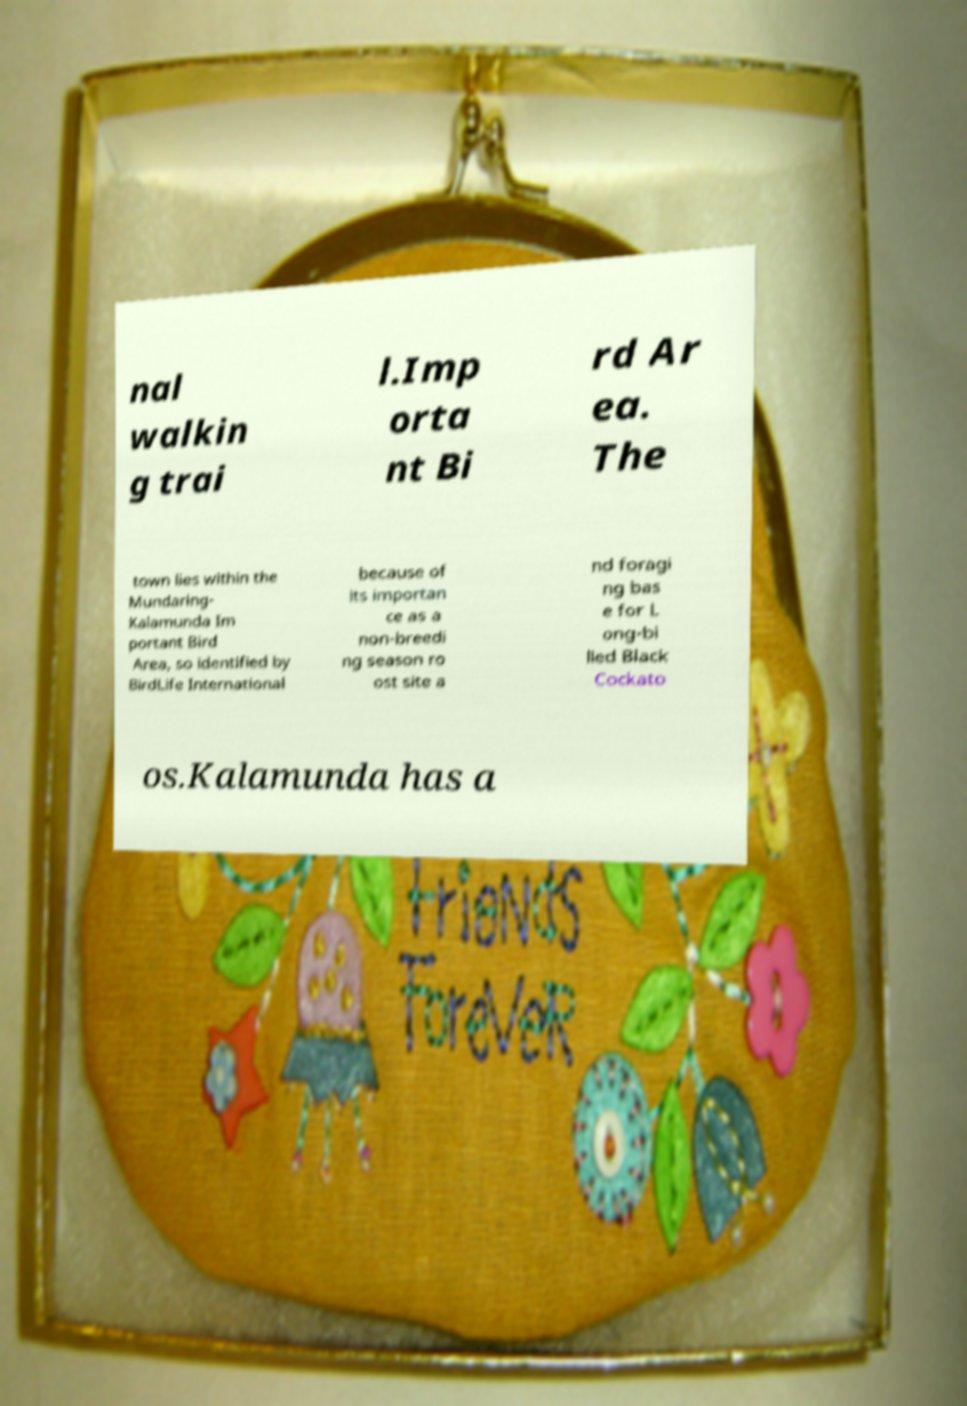Could you assist in decoding the text presented in this image and type it out clearly? nal walkin g trai l.Imp orta nt Bi rd Ar ea. The town lies within the Mundaring- Kalamunda Im portant Bird Area, so identified by BirdLife International because of its importan ce as a non-breedi ng season ro ost site a nd foragi ng bas e for L ong-bi lled Black Cockato os.Kalamunda has a 